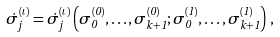Convert formula to latex. <formula><loc_0><loc_0><loc_500><loc_500>\dot { \sigma } _ { j } ^ { ( \iota ) } = \dot { \sigma } _ { j } ^ { ( \iota ) } \left ( \sigma _ { 0 } ^ { ( 0 ) } , \dots , \sigma _ { k + 1 } ^ { ( 0 ) } ; \sigma _ { 0 } ^ { ( 1 ) } , \dots , \sigma _ { k + 1 } ^ { ( 1 ) } \right ) \, ,</formula> 